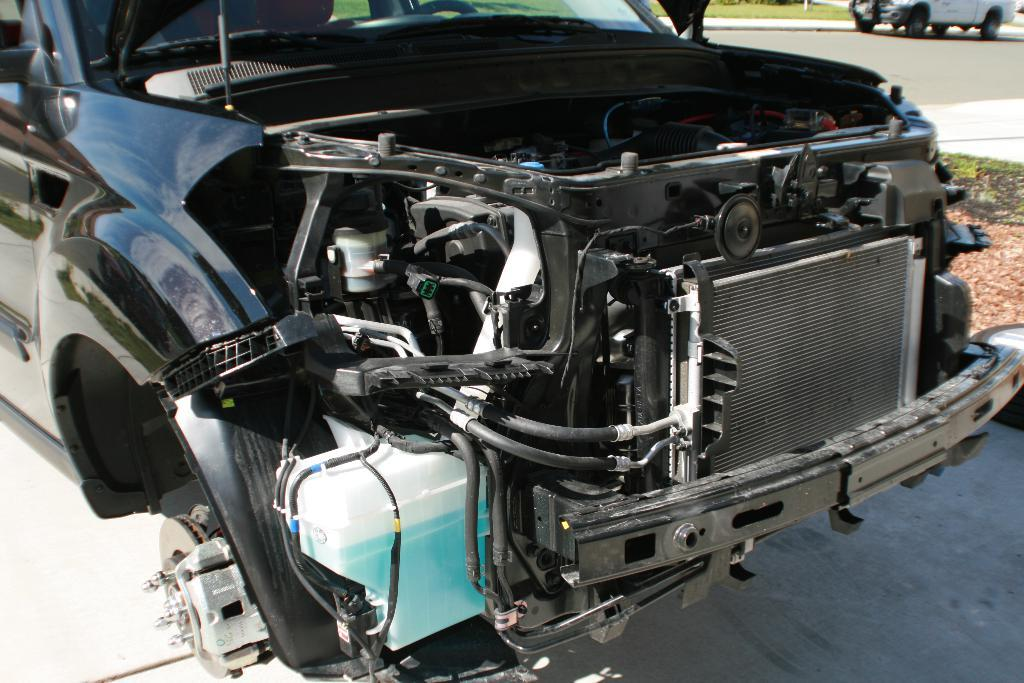What is the main focus of the image? The main focus of the image is a car with an open engine. Can you describe the condition of the car in the image? The car has an open engine, which suggests that it may be undergoing maintenance or repair. Are there any other cars visible in the image? Yes, there is another car visible on the road in the top right corner of the image. What type of lamp is illuminating the car's engine in the image? There is no lamp present in the image; the car's engine is open, but no light source is visible. 